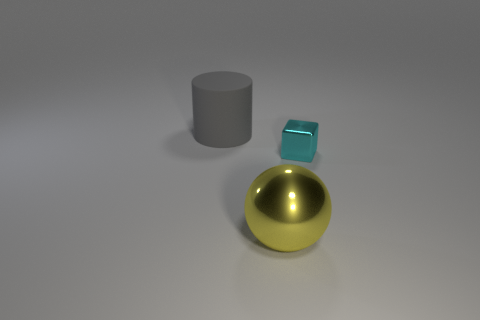Add 3 big yellow spheres. How many objects exist? 6 Subtract all cylinders. How many objects are left? 2 Subtract all large gray rubber objects. Subtract all large gray matte cylinders. How many objects are left? 1 Add 1 large cylinders. How many large cylinders are left? 2 Add 1 metallic things. How many metallic things exist? 3 Subtract 1 yellow balls. How many objects are left? 2 Subtract 1 cubes. How many cubes are left? 0 